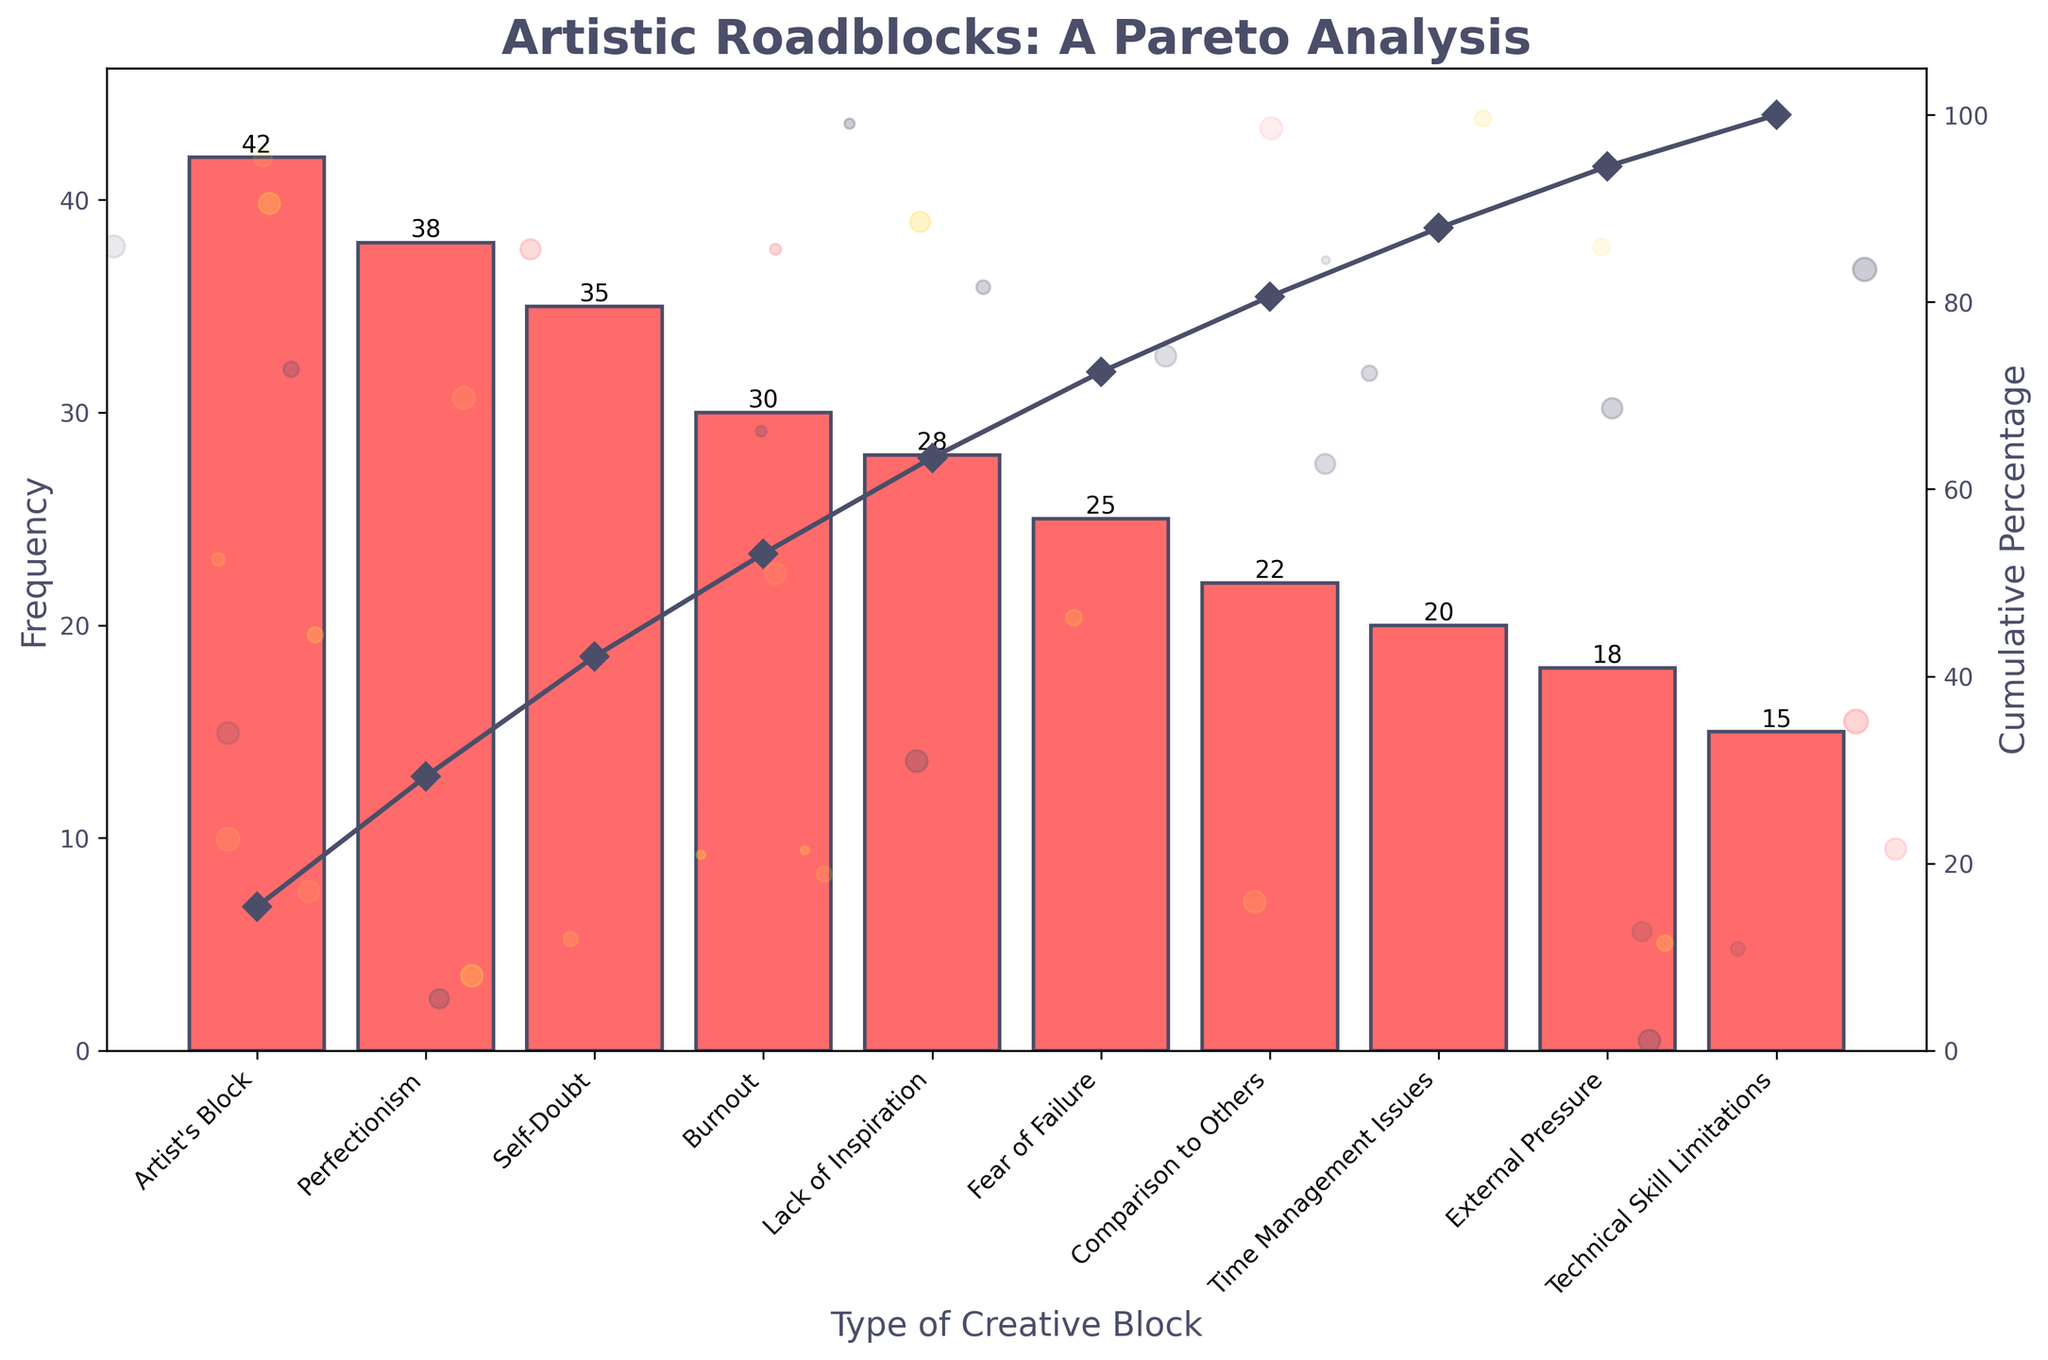What is the most common type of creative block according to the figure? The most common type of creative block appears at the leftmost bar in the Pareto chart, labeled "Artist's Block," which has the highest frequency.
Answer: Artist's Block How many types of creative blocks were surveyed in the chart? By counting the number of distinct bars on the x-axis of the Pareto chart, you can determine the number of surveyed creative blocks, which is ten.
Answer: Ten Which type of creative block is the least common? The least common type of creative block is identified by the shortest bar in the chart, labeled "Technical Skill Limitations."
Answer: Technical Skill Limitations What is the cumulative percentage of the top three creative blocks? The cumulative percentage line at the third bar ("Self-Doubt") will show the cumulative value. Look for where the cumulative percentage curve intersects above the third bar. The value is around 69.8%.
Answer: Approximately 69.8% What is the cumulative percentage after including "Burnout"? To find the cumulative percentage up to "Burnout," locate the fourth bar and trace the cumulative percentage line to read the value, which is around 83.7%.
Answer: Approximately 83.7% How does the frequency of "Perfectionism" compare to "Artist's Block"? "Perfectionism," the second bar, has a slightly lower frequency than "Artist's Block," the first bar. The frequency of "Perfectionism" is 38, while "Artist's Block" is 42.
Answer: "Perfectionism" is 4 less than "Artist's Block" Which creative block contributes approximately to the first 50% of the cumulative percentage? Find the point on the cumulative percentage line where it reaches around 50%. The corresponding bar under that point is "Self-Doubt".
Answer: Self-Doubt What’s the total frequency of "Comparison to Others" and "Lack of Inspiration"? Add the individual frequencies: "Comparison to Others" is 22, and "Lack of Inspiration" is 28. 22 + 28 = 50.
Answer: 50 Is "Fear of Failure" more or less frequent than "Time Management Issues"? Compare the height of the bars. "Fear of Failure" has a frequency of 25, which is higher than "Time Management Issues" with a frequency of 20.
Answer: More frequent What's the frequency difference between the most and least common creative blocks? Subtract the frequency of the least common block ("Technical Skill Limitations" with 15) from the most common block ("Artist's Block" with 42). 42 - 15 = 27.
Answer: 27 